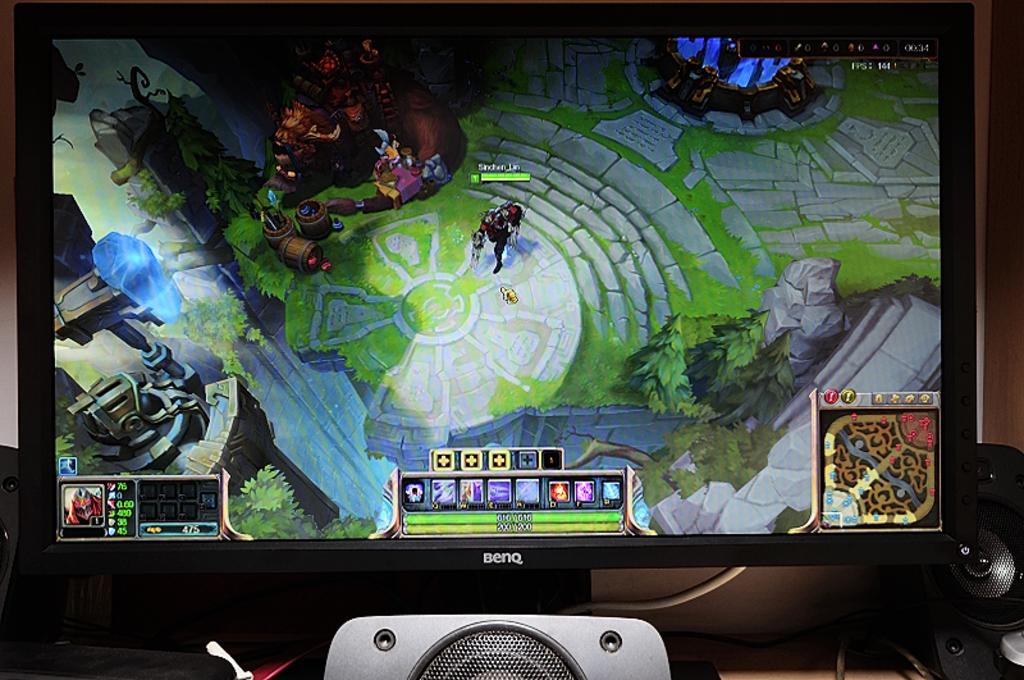<image>
Summarize the visual content of the image. A videogame on a black BENQ monitor with speakers 